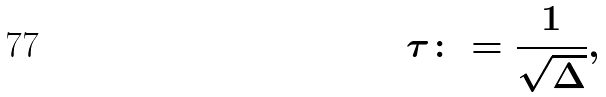Convert formula to latex. <formula><loc_0><loc_0><loc_500><loc_500>\tau \colon = \frac { 1 } { \sqrt { \Delta } } ,</formula> 